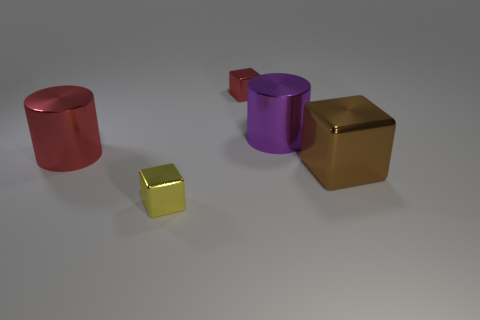Is the material of the big purple thing the same as the tiny thing that is behind the large purple metal cylinder? While the objects appear to be rendered in a similar shiny texture suggesting a metallic finish, it's not possible to confirm if the materials are exactly the same without additional information. However, the reflective properties and the consistency of the surface finishing techniques imply that they could be made of similar substances, possibly intended to be a visual representation of metals in a 3D graphics context. 